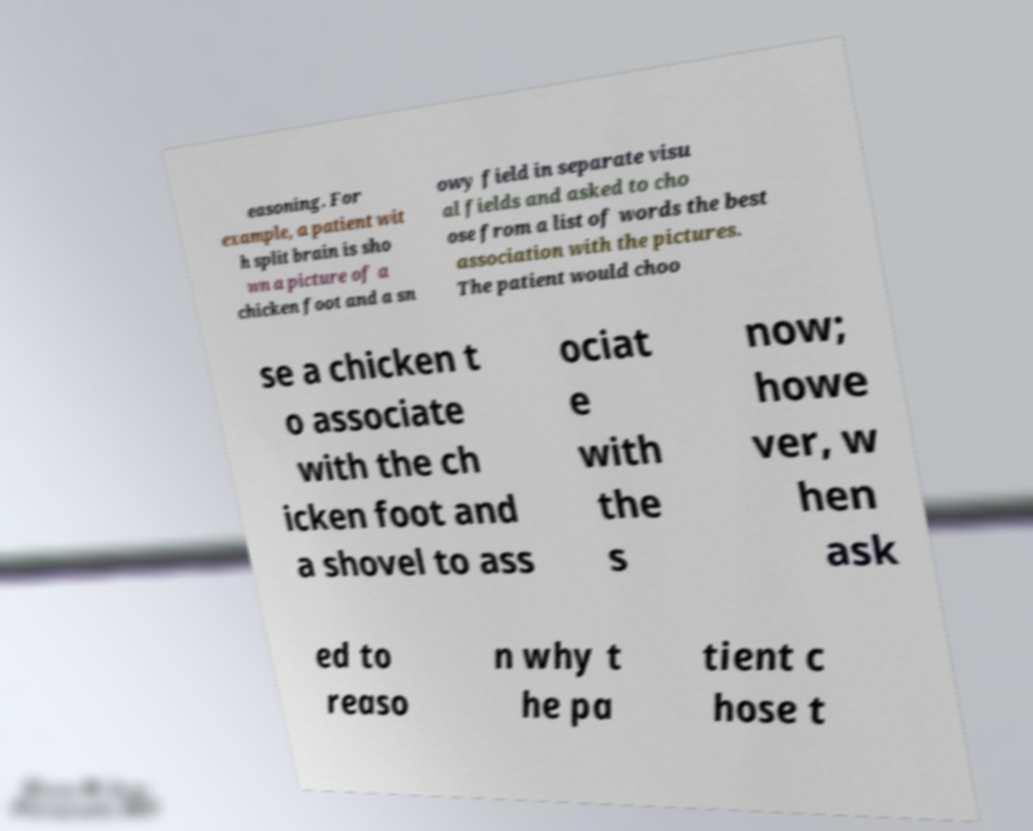Can you read and provide the text displayed in the image?This photo seems to have some interesting text. Can you extract and type it out for me? easoning. For example, a patient wit h split brain is sho wn a picture of a chicken foot and a sn owy field in separate visu al fields and asked to cho ose from a list of words the best association with the pictures. The patient would choo se a chicken t o associate with the ch icken foot and a shovel to ass ociat e with the s now; howe ver, w hen ask ed to reaso n why t he pa tient c hose t 